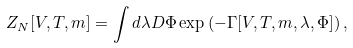Convert formula to latex. <formula><loc_0><loc_0><loc_500><loc_500>Z _ { N } [ V , T , m ] = \int d \lambda D \Phi \exp \left ( - \Gamma [ V , T , m , \lambda , \Phi ] \right ) ,</formula> 